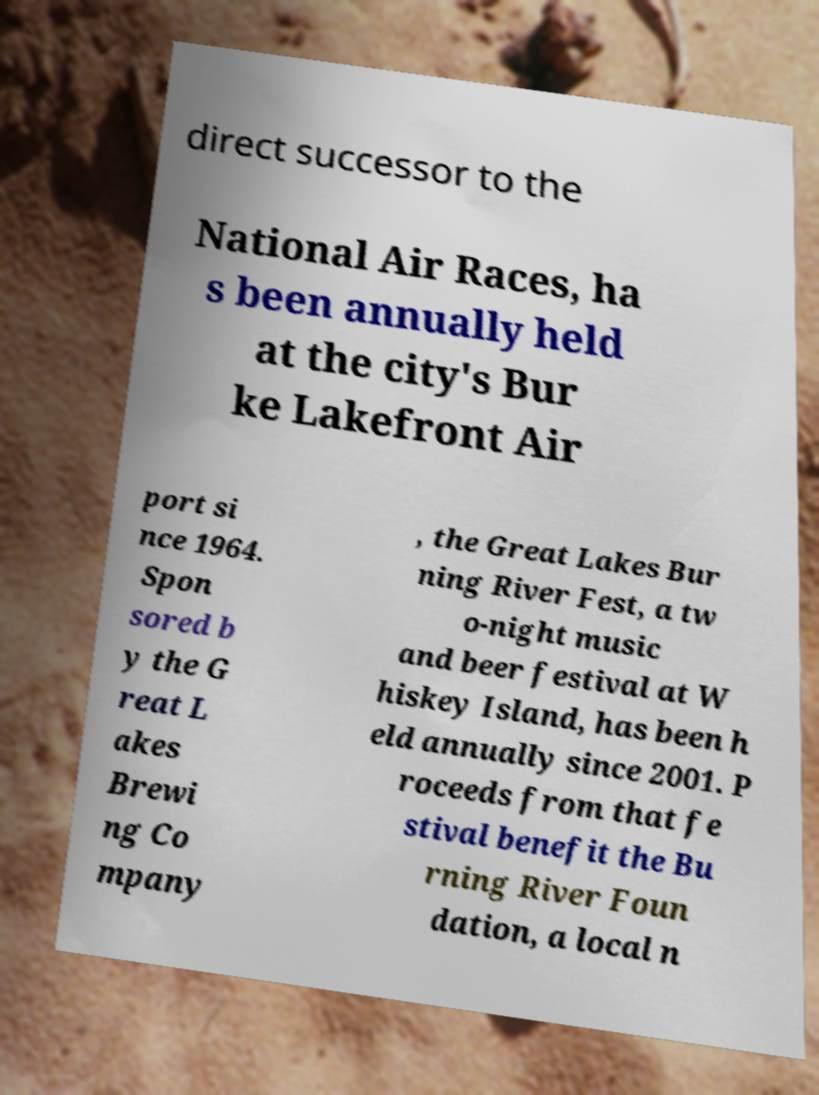There's text embedded in this image that I need extracted. Can you transcribe it verbatim? direct successor to the National Air Races, ha s been annually held at the city's Bur ke Lakefront Air port si nce 1964. Spon sored b y the G reat L akes Brewi ng Co mpany , the Great Lakes Bur ning River Fest, a tw o-night music and beer festival at W hiskey Island, has been h eld annually since 2001. P roceeds from that fe stival benefit the Bu rning River Foun dation, a local n 